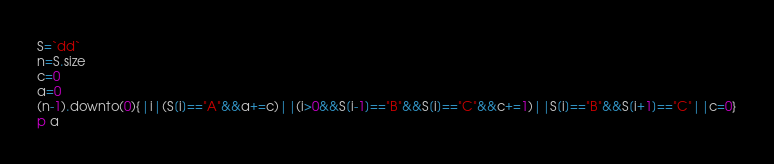<code> <loc_0><loc_0><loc_500><loc_500><_Ruby_>S=`dd`
n=S.size
c=0
a=0
(n-1).downto(0){|i|(S[i]=="A"&&a+=c)||(i>0&&S[i-1]=="B"&&S[i]=="C"&&c+=1)||S[i]=="B"&&S[i+1]=="C"||c=0}
p a</code> 